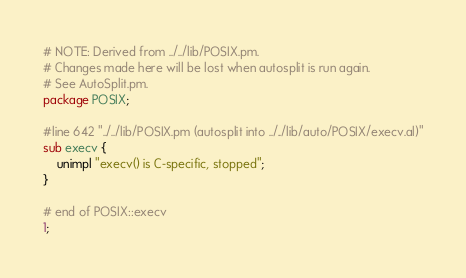Convert code to text. <code><loc_0><loc_0><loc_500><loc_500><_Perl_># NOTE: Derived from ../../lib/POSIX.pm.
# Changes made here will be lost when autosplit is run again.
# See AutoSplit.pm.
package POSIX;

#line 642 "../../lib/POSIX.pm (autosplit into ../../lib/auto/POSIX/execv.al)"
sub execv {
    unimpl "execv() is C-specific, stopped";
}

# end of POSIX::execv
1;
</code> 